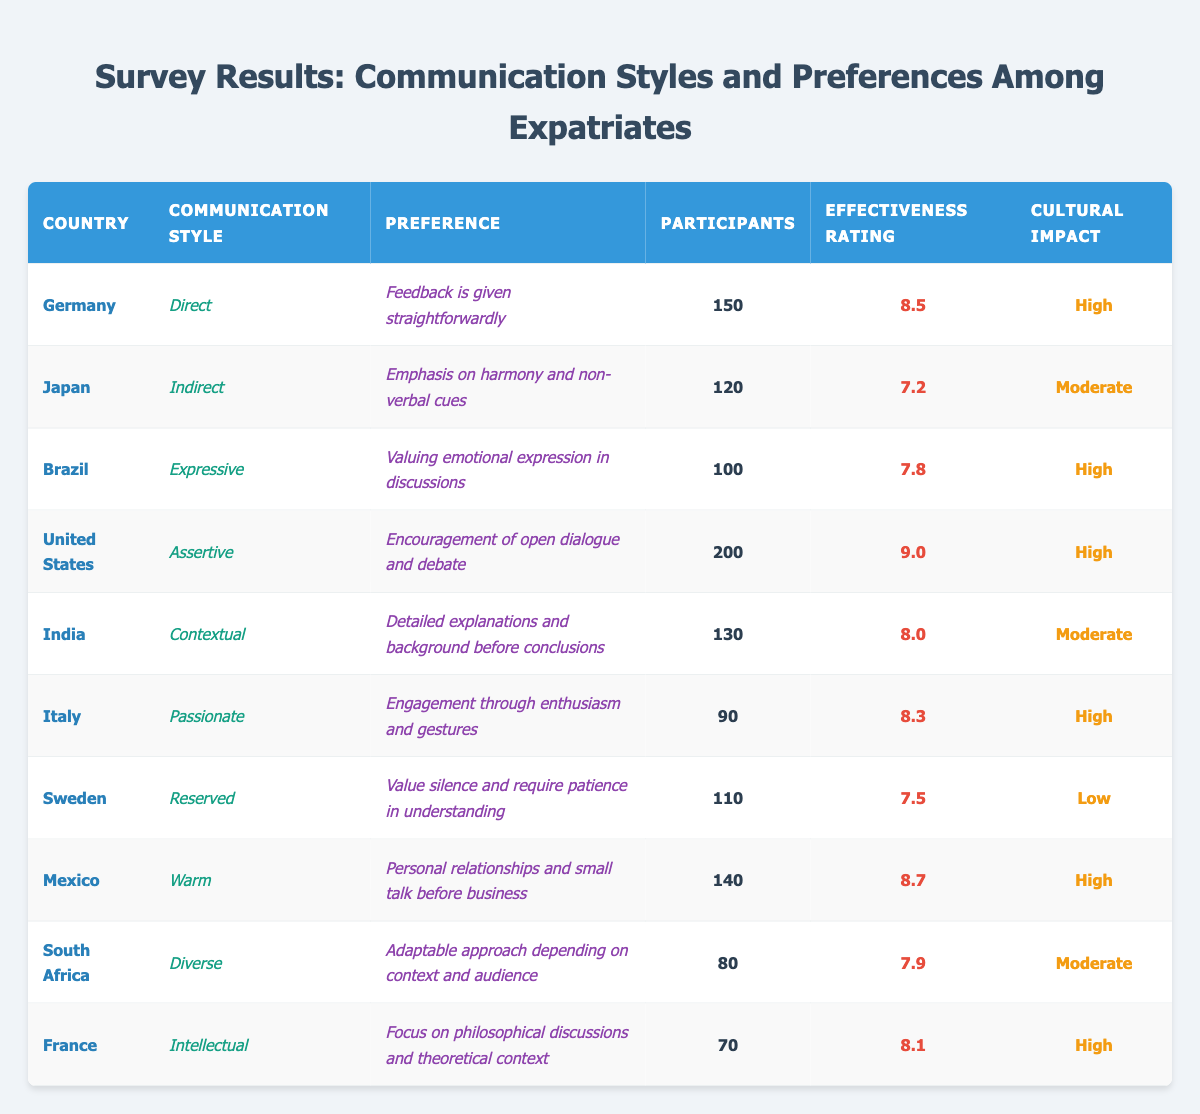What is the communication style used in Germany? The table lists Germany under the "Country" column, with "Direct" noted in the "Communication Style" column.
Answer: Direct How many participants from the United States responded to the survey? In the "Participants" column for the United States, it shows a value of 200.
Answer: 200 Which country has the lowest effectiveness rating? The effectiveness ratings are listed, and the lowest rating of 7.2 corresponds to Japan.
Answer: Japan What is the average effectiveness rating of all countries surveyed? The total effectiveness ratings are 8.5 + 7.2 + 7.8 + 9.0 + 8.0 + 8.3 + 7.5 + 8.7 + 7.9 + 8.1 = 81.0. There are 10 countries, so the average is 81.0/10 = 8.1.
Answer: 8.1 Which countries have a cultural impact rated as "High"? By analyzing the "Cultural Impact" column, the countries marked with "High" are Germany, Brazil, United States, Italy, Mexico, and France.
Answer: Germany, Brazil, United States, Italy, Mexico, France Is it true that Brazil has a preference for emotional expression in discussions? The table shows Brazil with the preference listed as "Valuing emotional expression in discussions," confirming that this statement is true.
Answer: True What is the communication style of the country with 80 participants? The row corresponding to South Africa lists 80 participants and indicates its communication style as "Diverse."
Answer: Diverse Compare the effectiveness ratings of the countries with the "Warm" and "Reserved" communication styles. Mexico, which has a "Warm" style, has an effectiveness rating of 8.7, while Sweden, with a "Reserved" style, has a rating of 7.5. The difference is 8.7 - 7.5 = 1.2, meaning Mexico's rating is higher.
Answer: 1.2 Which country has a higher effectiveness rating: India or Japan? Comparing the effectiveness ratings, India is rated 8.0 and Japan 7.2; thus, 8.0 > 7.2, which shows India has a higher rating.
Answer: India What communication style is associated with personal relationships and small talk before business? The table shows Mexico's preference as "Personal relationships and small talk before business," linked to its "Warm" communication style.
Answer: Warm 